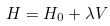<formula> <loc_0><loc_0><loc_500><loc_500>H = H _ { 0 } + \lambda V</formula> 